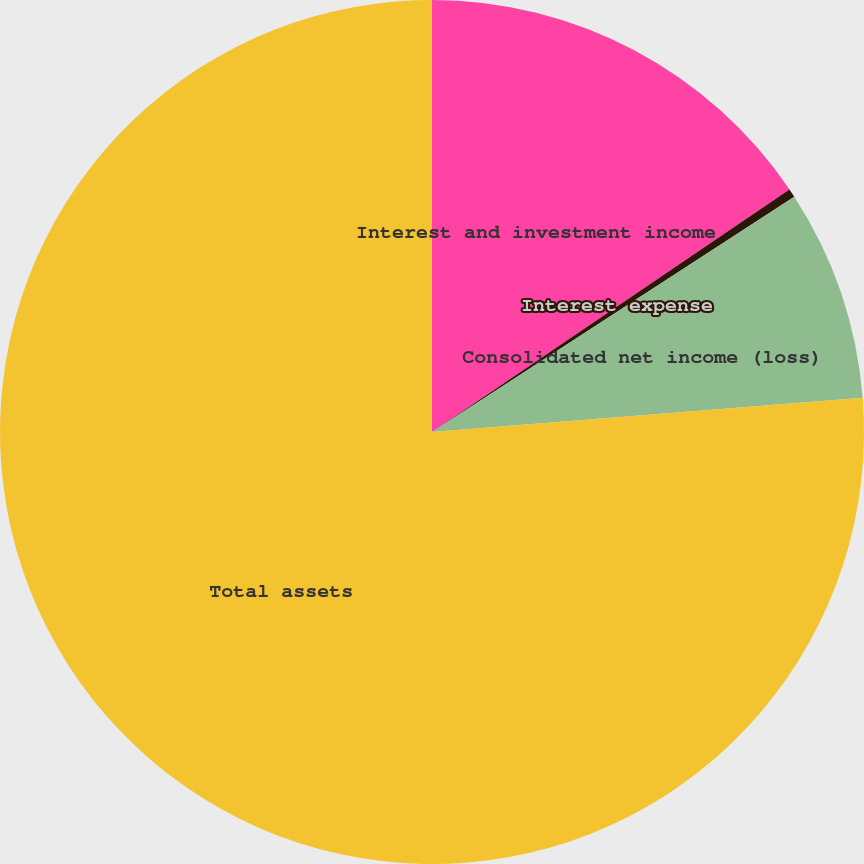<chart> <loc_0><loc_0><loc_500><loc_500><pie_chart><fcel>Interest and investment income<fcel>Interest expense<fcel>Consolidated net income (loss)<fcel>Total assets<nl><fcel>15.51%<fcel>0.32%<fcel>7.91%<fcel>76.26%<nl></chart> 